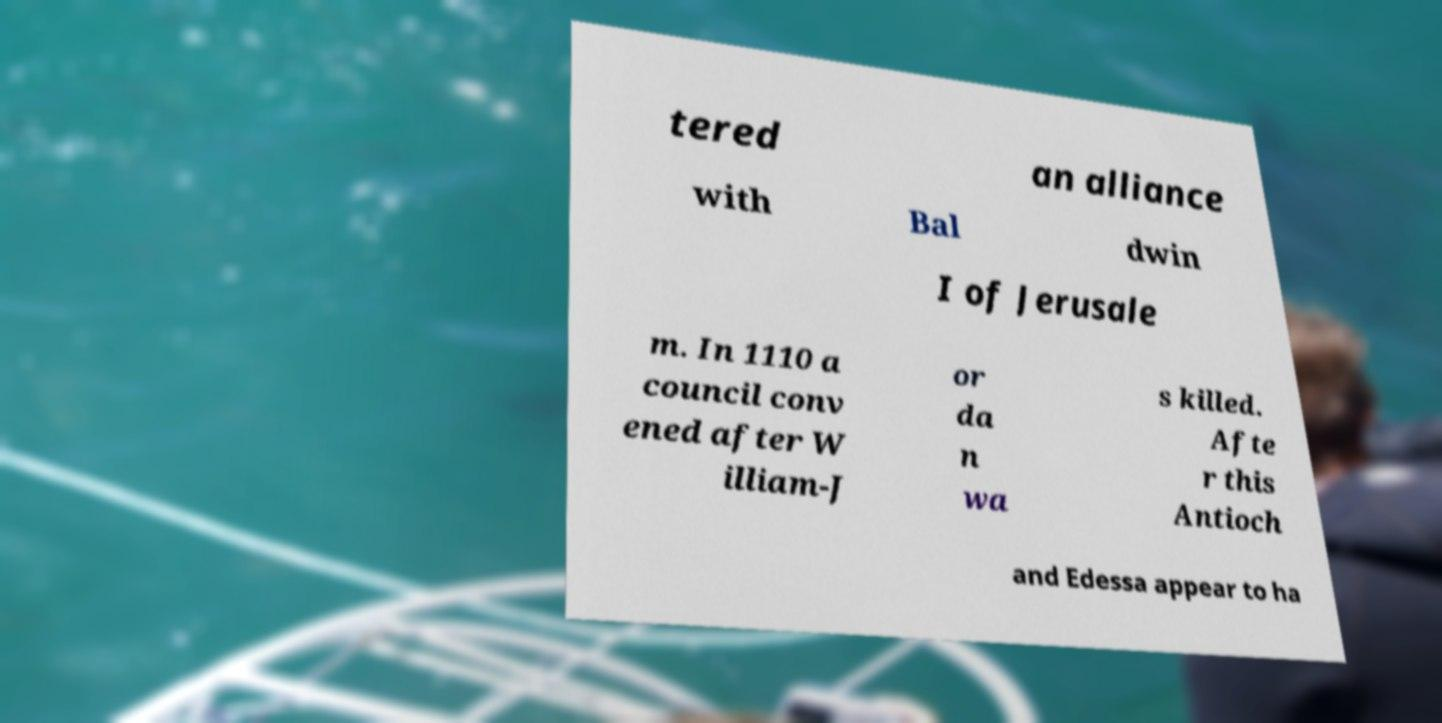Can you read and provide the text displayed in the image?This photo seems to have some interesting text. Can you extract and type it out for me? tered an alliance with Bal dwin I of Jerusale m. In 1110 a council conv ened after W illiam-J or da n wa s killed. Afte r this Antioch and Edessa appear to ha 